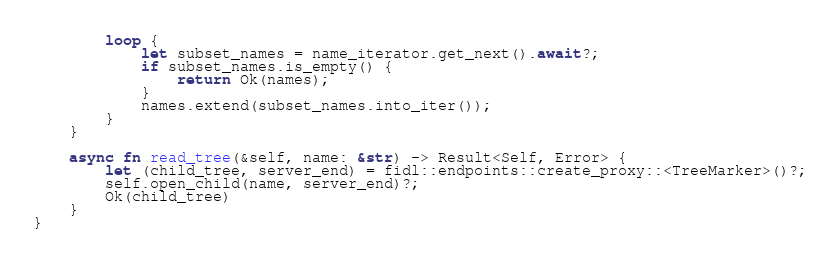Convert code to text. <code><loc_0><loc_0><loc_500><loc_500><_Rust_>        loop {
            let subset_names = name_iterator.get_next().await?;
            if subset_names.is_empty() {
                return Ok(names);
            }
            names.extend(subset_names.into_iter());
        }
    }

    async fn read_tree(&self, name: &str) -> Result<Self, Error> {
        let (child_tree, server_end) = fidl::endpoints::create_proxy::<TreeMarker>()?;
        self.open_child(name, server_end)?;
        Ok(child_tree)
    }
}
</code> 